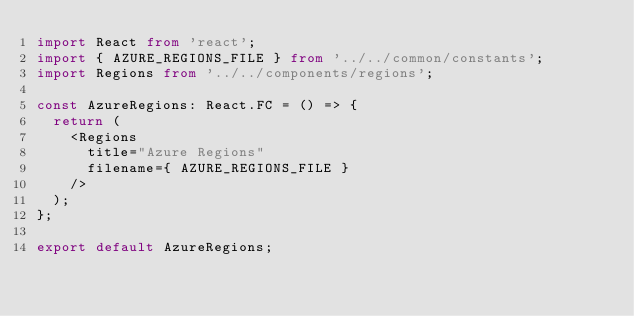<code> <loc_0><loc_0><loc_500><loc_500><_TypeScript_>import React from 'react';
import { AZURE_REGIONS_FILE } from '../../common/constants';
import Regions from '../../components/regions';

const AzureRegions: React.FC = () => {
  return (
    <Regions
      title="Azure Regions"
      filename={ AZURE_REGIONS_FILE }
    />
  );
};

export default AzureRegions;
</code> 